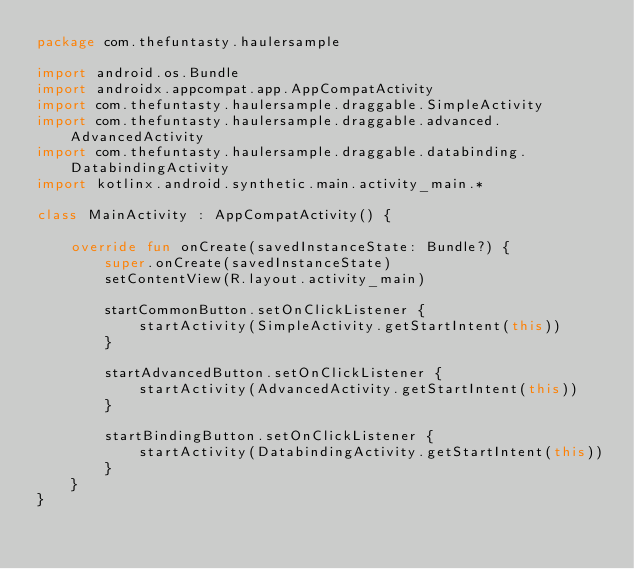Convert code to text. <code><loc_0><loc_0><loc_500><loc_500><_Kotlin_>package com.thefuntasty.haulersample

import android.os.Bundle
import androidx.appcompat.app.AppCompatActivity
import com.thefuntasty.haulersample.draggable.SimpleActivity
import com.thefuntasty.haulersample.draggable.advanced.AdvancedActivity
import com.thefuntasty.haulersample.draggable.databinding.DatabindingActivity
import kotlinx.android.synthetic.main.activity_main.*

class MainActivity : AppCompatActivity() {

    override fun onCreate(savedInstanceState: Bundle?) {
        super.onCreate(savedInstanceState)
        setContentView(R.layout.activity_main)

        startCommonButton.setOnClickListener {
            startActivity(SimpleActivity.getStartIntent(this))
        }

        startAdvancedButton.setOnClickListener {
            startActivity(AdvancedActivity.getStartIntent(this))
        }

        startBindingButton.setOnClickListener {
            startActivity(DatabindingActivity.getStartIntent(this))
        }
    }
}
</code> 